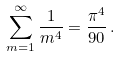<formula> <loc_0><loc_0><loc_500><loc_500>\sum _ { m = 1 } ^ { \infty } \frac { 1 } { m ^ { 4 } } = \frac { \pi ^ { 4 } } { 9 0 } \, .</formula> 